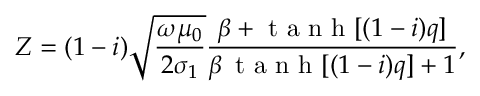Convert formula to latex. <formula><loc_0><loc_0><loc_500><loc_500>Z = ( 1 - i ) \sqrt { \frac { \omega \mu _ { 0 } } { 2 \sigma _ { 1 } } } \frac { \beta + t a n h [ ( 1 - i ) q ] } { \beta \, t a n h [ ( 1 - i ) q ] + 1 } ,</formula> 